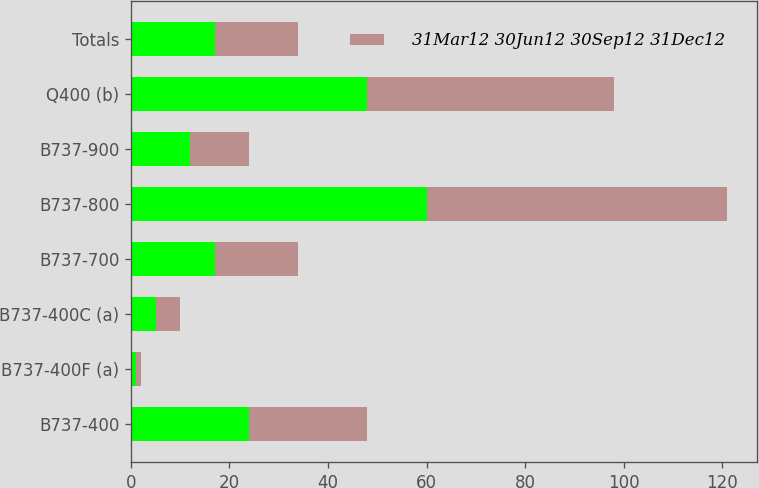<chart> <loc_0><loc_0><loc_500><loc_500><stacked_bar_chart><ecel><fcel>B737-400<fcel>B737-400F (a)<fcel>B737-400C (a)<fcel>B737-700<fcel>B737-800<fcel>B737-900<fcel>Q400 (b)<fcel>Totals<nl><fcel>nan<fcel>24<fcel>1<fcel>5<fcel>17<fcel>60<fcel>12<fcel>48<fcel>17<nl><fcel>31Mar12 30Jun12 30Sep12 31Dec12<fcel>24<fcel>1<fcel>5<fcel>17<fcel>61<fcel>12<fcel>50<fcel>17<nl></chart> 